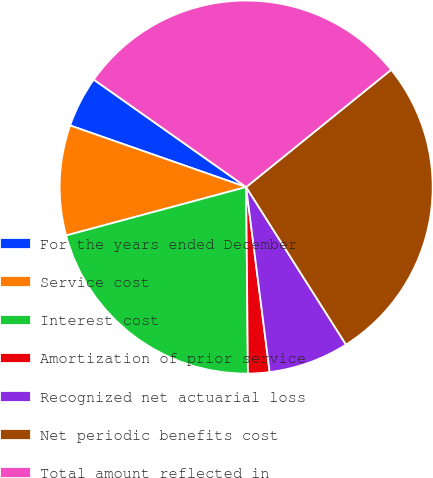Convert chart to OTSL. <chart><loc_0><loc_0><loc_500><loc_500><pie_chart><fcel>For the years ended December<fcel>Service cost<fcel>Interest cost<fcel>Amortization of prior service<fcel>Recognized net actuarial loss<fcel>Net periodic benefits cost<fcel>Total amount reflected in<nl><fcel>4.42%<fcel>9.54%<fcel>20.97%<fcel>1.86%<fcel>6.98%<fcel>26.84%<fcel>29.4%<nl></chart> 